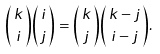<formula> <loc_0><loc_0><loc_500><loc_500>\binom { \, k \, } { i } \binom { \, i \, } { j } = \binom { \, k \, } { j } \binom { \, k - j \, } { i - j } .</formula> 